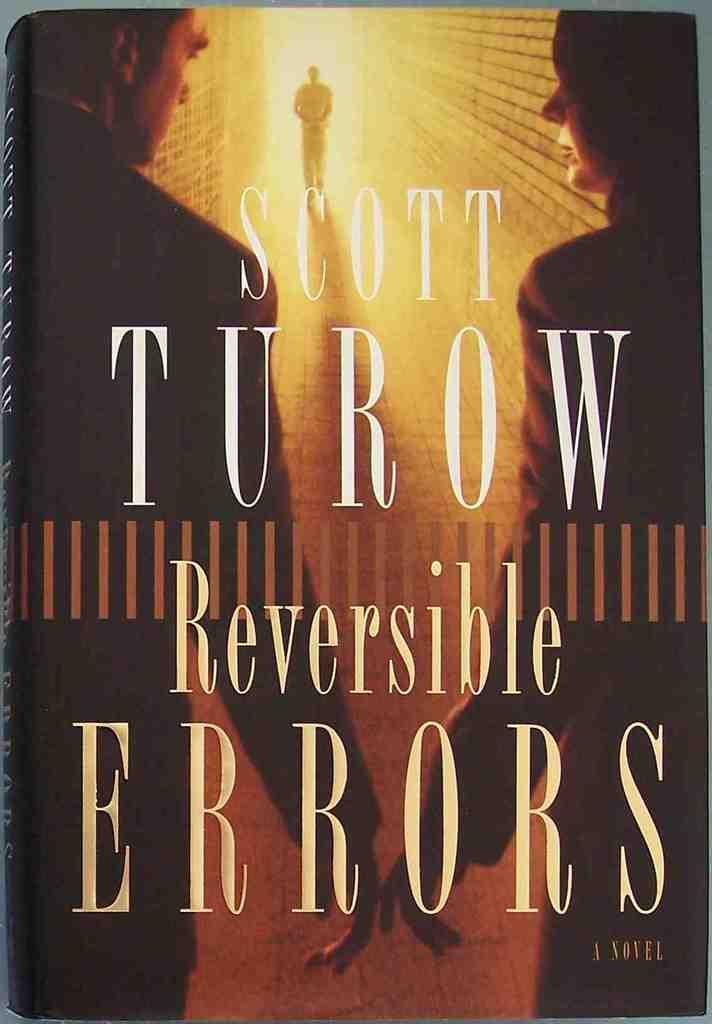What is the name of the author?
Keep it short and to the point. Scott turow. 